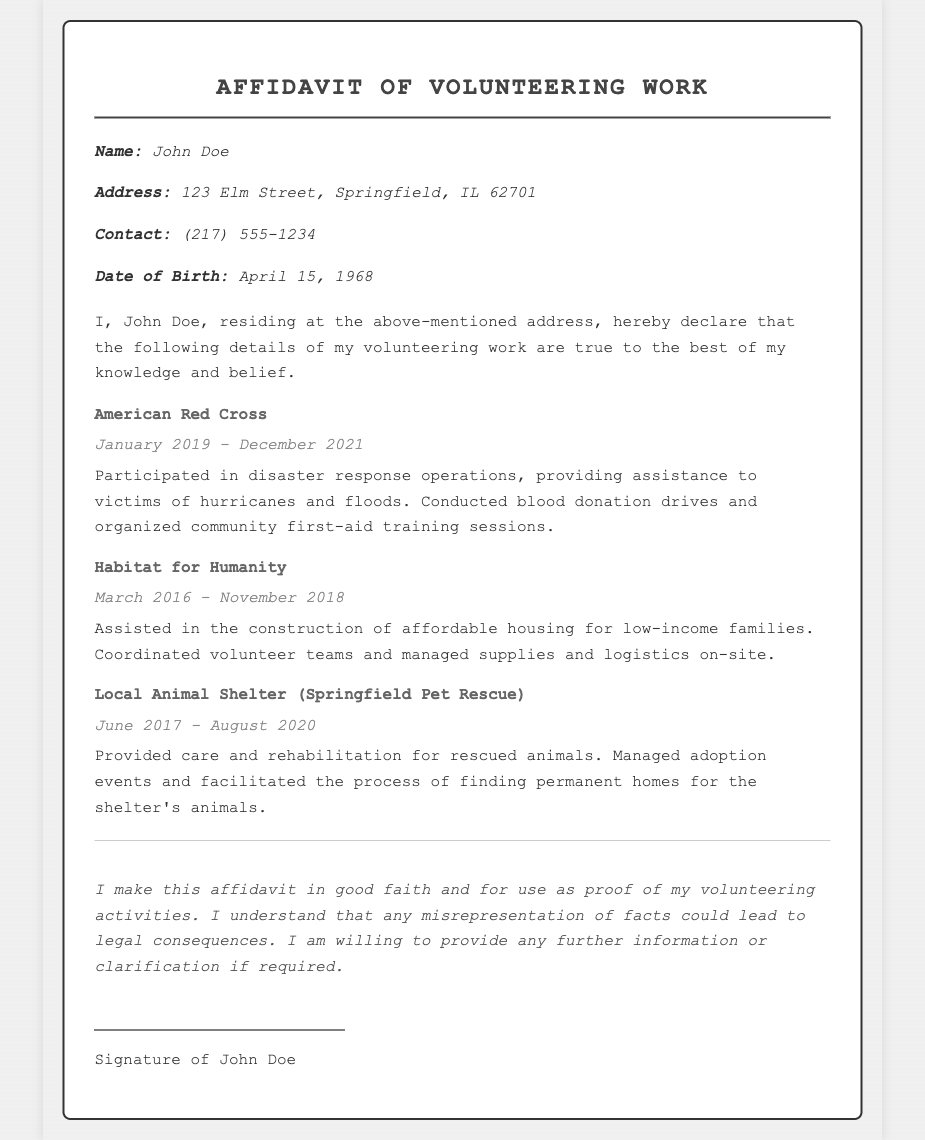What is the affiant's name? The affiant's name is specified at the beginning of the affidavit.
Answer: John Doe What is the affiant's address? The affiant's address is listed in the details section.
Answer: 123 Elm Street, Springfield, IL 62701 What organization did the affiant volunteer for between January 2019 and December 2021? The organization is mentioned along with the duration of service.
Answer: American Red Cross How long did the affiant volunteer for Habitat for Humanity? The duration of service for this organization is provided in the document.
Answer: March 2016 - November 2018 What type of services did the affiant provide at the Local Animal Shelter? The nature of services is described for each organization.
Answer: Provided care and rehabilitation for rescued animals What were the main activities of the affiant with the American Red Cross? Information about specific types of activities is included in the affidavit.
Answer: Disaster response operations What date of birth is recorded for the affiant? The specific date of birth is mentioned in the affiant details.
Answer: April 15, 1968 What does the affiant declare about the accuracy of the information? The declaration emphasizes the belief in the truth of the information provided.
Answer: True to the best of my knowledge and belief What is the consequence of misrepresentation mentioned in the affidavit? The affidavit outlines potential consequences related to false information.
Answer: Legal consequences 